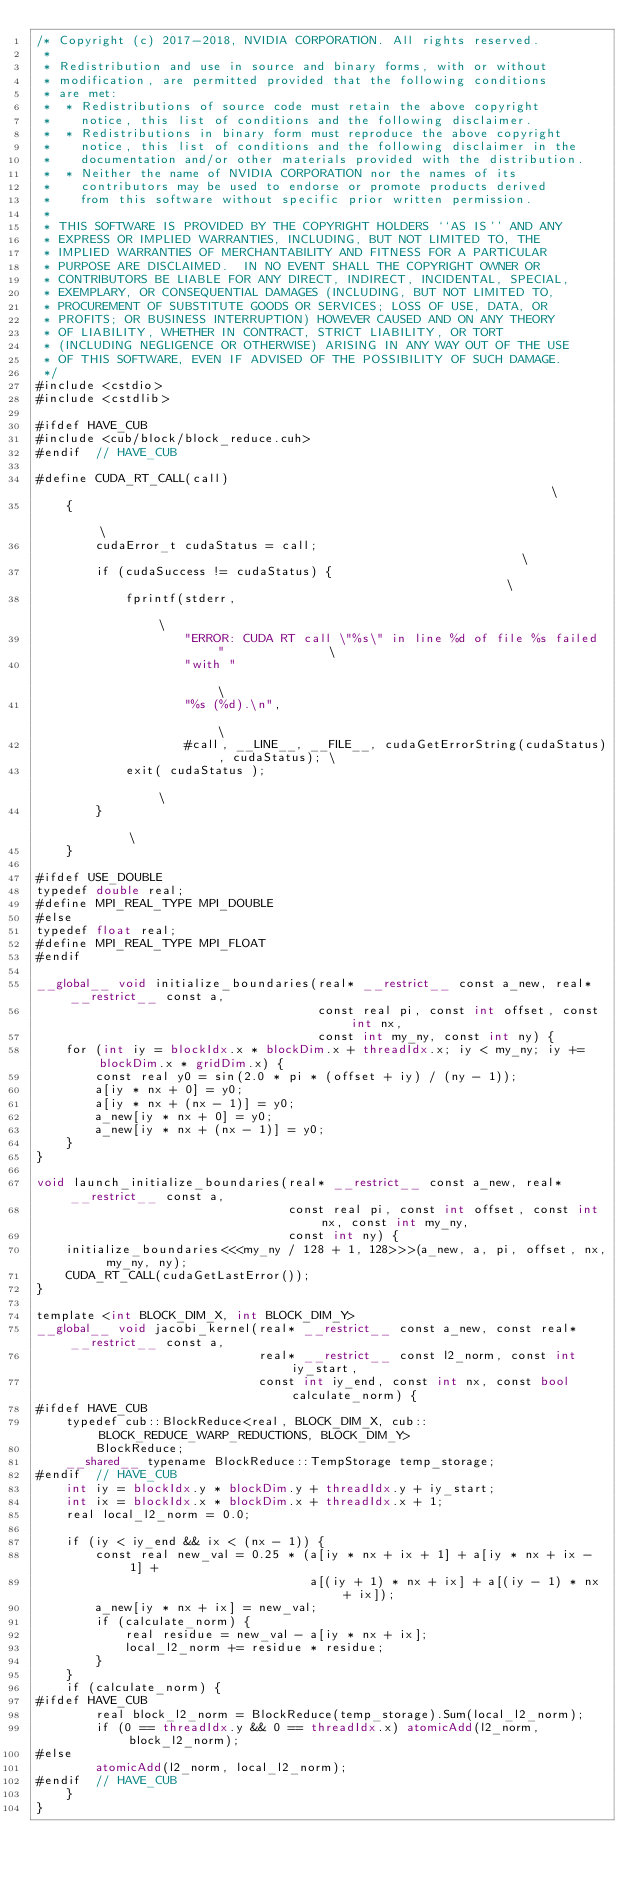Convert code to text. <code><loc_0><loc_0><loc_500><loc_500><_Cuda_>/* Copyright (c) 2017-2018, NVIDIA CORPORATION. All rights reserved.
 *
 * Redistribution and use in source and binary forms, with or without
 * modification, are permitted provided that the following conditions
 * are met:
 *  * Redistributions of source code must retain the above copyright
 *    notice, this list of conditions and the following disclaimer.
 *  * Redistributions in binary form must reproduce the above copyright
 *    notice, this list of conditions and the following disclaimer in the
 *    documentation and/or other materials provided with the distribution.
 *  * Neither the name of NVIDIA CORPORATION nor the names of its
 *    contributors may be used to endorse or promote products derived
 *    from this software without specific prior written permission.
 *
 * THIS SOFTWARE IS PROVIDED BY THE COPYRIGHT HOLDERS ``AS IS'' AND ANY
 * EXPRESS OR IMPLIED WARRANTIES, INCLUDING, BUT NOT LIMITED TO, THE
 * IMPLIED WARRANTIES OF MERCHANTABILITY AND FITNESS FOR A PARTICULAR
 * PURPOSE ARE DISCLAIMED.  IN NO EVENT SHALL THE COPYRIGHT OWNER OR
 * CONTRIBUTORS BE LIABLE FOR ANY DIRECT, INDIRECT, INCIDENTAL, SPECIAL,
 * EXEMPLARY, OR CONSEQUENTIAL DAMAGES (INCLUDING, BUT NOT LIMITED TO,
 * PROCUREMENT OF SUBSTITUTE GOODS OR SERVICES; LOSS OF USE, DATA, OR
 * PROFITS; OR BUSINESS INTERRUPTION) HOWEVER CAUSED AND ON ANY THEORY
 * OF LIABILITY, WHETHER IN CONTRACT, STRICT LIABILITY, OR TORT
 * (INCLUDING NEGLIGENCE OR OTHERWISE) ARISING IN ANY WAY OUT OF THE USE
 * OF THIS SOFTWARE, EVEN IF ADVISED OF THE POSSIBILITY OF SUCH DAMAGE.
 */
#include <cstdio>
#include <cstdlib>

#ifdef HAVE_CUB
#include <cub/block/block_reduce.cuh>
#endif  // HAVE_CUB

#define CUDA_RT_CALL(call)                                                                  \
    {                                                                                       \
        cudaError_t cudaStatus = call;                                                      \
        if (cudaSuccess != cudaStatus) {                                                    \
            fprintf(stderr,                                                                 \
                    "ERROR: CUDA RT call \"%s\" in line %d of file %s failed "              \
                    "with "                                                                 \
                    "%s (%d).\n",                                                           \
                    #call, __LINE__, __FILE__, cudaGetErrorString(cudaStatus), cudaStatus); \
            exit( cudaStatus );                                                             \
        }                                                                                   \
    }

#ifdef USE_DOUBLE
typedef double real;
#define MPI_REAL_TYPE MPI_DOUBLE
#else
typedef float real;
#define MPI_REAL_TYPE MPI_FLOAT
#endif

__global__ void initialize_boundaries(real* __restrict__ const a_new, real* __restrict__ const a,
                                      const real pi, const int offset, const int nx,
                                      const int my_ny, const int ny) {
    for (int iy = blockIdx.x * blockDim.x + threadIdx.x; iy < my_ny; iy += blockDim.x * gridDim.x) {
        const real y0 = sin(2.0 * pi * (offset + iy) / (ny - 1));
        a[iy * nx + 0] = y0;
        a[iy * nx + (nx - 1)] = y0;
        a_new[iy * nx + 0] = y0;
        a_new[iy * nx + (nx - 1)] = y0;
    }
}

void launch_initialize_boundaries(real* __restrict__ const a_new, real* __restrict__ const a,
                                  const real pi, const int offset, const int nx, const int my_ny,
                                  const int ny) {
    initialize_boundaries<<<my_ny / 128 + 1, 128>>>(a_new, a, pi, offset, nx, my_ny, ny);
    CUDA_RT_CALL(cudaGetLastError());
}

template <int BLOCK_DIM_X, int BLOCK_DIM_Y>
__global__ void jacobi_kernel(real* __restrict__ const a_new, const real* __restrict__ const a,
                              real* __restrict__ const l2_norm, const int iy_start,
                              const int iy_end, const int nx, const bool calculate_norm) {
#ifdef HAVE_CUB
    typedef cub::BlockReduce<real, BLOCK_DIM_X, cub::BLOCK_REDUCE_WARP_REDUCTIONS, BLOCK_DIM_Y>
        BlockReduce;
    __shared__ typename BlockReduce::TempStorage temp_storage;
#endif  // HAVE_CUB
    int iy = blockIdx.y * blockDim.y + threadIdx.y + iy_start;
    int ix = blockIdx.x * blockDim.x + threadIdx.x + 1;
    real local_l2_norm = 0.0;

    if (iy < iy_end && ix < (nx - 1)) {
        const real new_val = 0.25 * (a[iy * nx + ix + 1] + a[iy * nx + ix - 1] +
                                     a[(iy + 1) * nx + ix] + a[(iy - 1) * nx + ix]);
        a_new[iy * nx + ix] = new_val;
        if (calculate_norm) {
            real residue = new_val - a[iy * nx + ix];
            local_l2_norm += residue * residue;
        }
    }
    if (calculate_norm) {
#ifdef HAVE_CUB
        real block_l2_norm = BlockReduce(temp_storage).Sum(local_l2_norm);
        if (0 == threadIdx.y && 0 == threadIdx.x) atomicAdd(l2_norm, block_l2_norm);
#else
        atomicAdd(l2_norm, local_l2_norm);
#endif  // HAVE_CUB
    }
}
</code> 